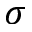Convert formula to latex. <formula><loc_0><loc_0><loc_500><loc_500>\sigma</formula> 